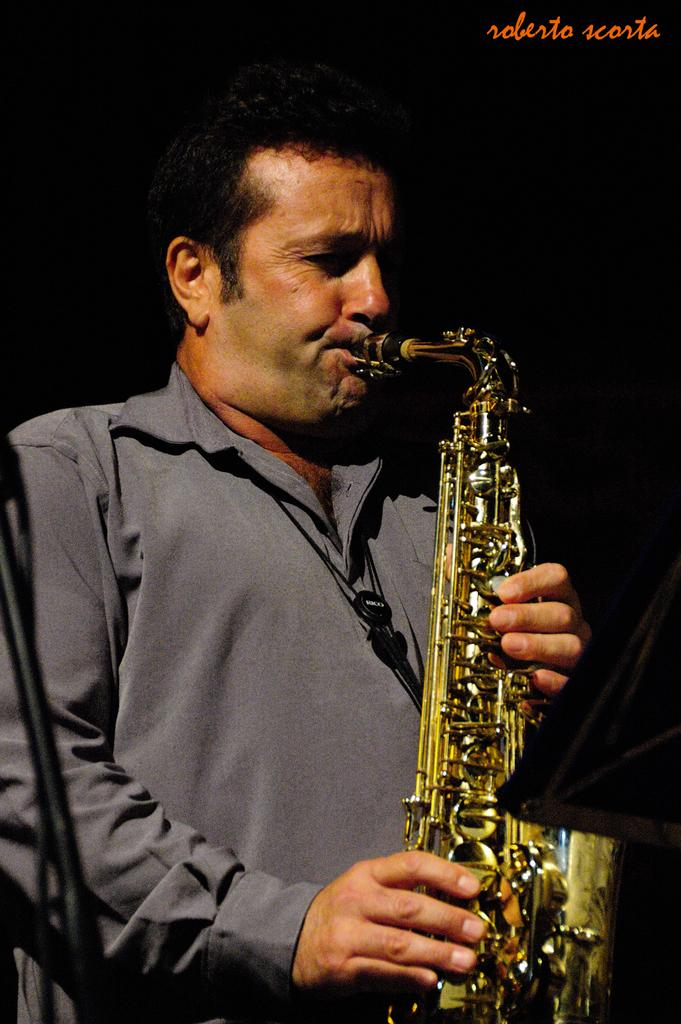What is the main subject of the image? The main subject of the image is a man. What is the man doing in the image? The man is standing and playing a musical instrument. How is the musical instrument being played by the man? The musical instrument is held with the man's mouth. What color jacket is the man wearing? The man is wearing a gray color jacket. How many snakes are wrapped around the man's legs in the image? There are no snakes present in the image. What type of store is visible in the background of the image? There is no store visible in the image; it only features the man playing a musical instrument. 